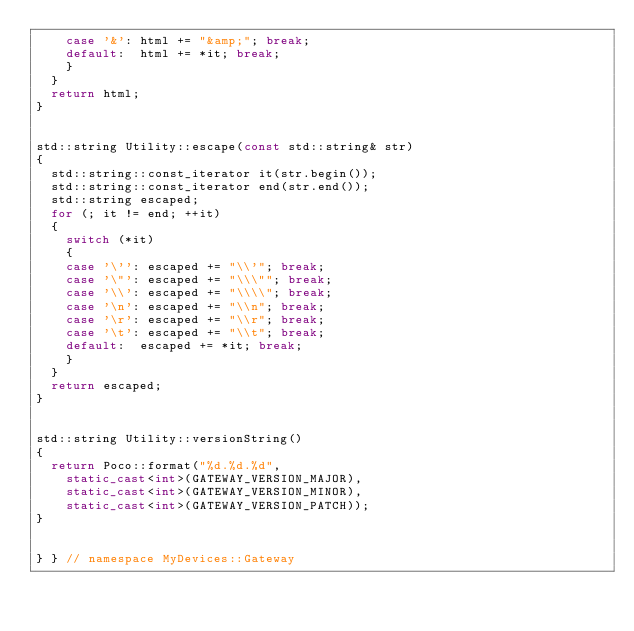Convert code to text. <code><loc_0><loc_0><loc_500><loc_500><_C++_>		case '&': html += "&amp;"; break;
		default:  html += *it; break;
		}
	}
	return html;
}


std::string Utility::escape(const std::string& str)
{
	std::string::const_iterator it(str.begin());
	std::string::const_iterator end(str.end());
	std::string escaped;
	for (; it != end; ++it)
	{
		switch (*it)
		{
		case '\'': escaped += "\\'"; break;
		case '\"': escaped += "\\\""; break;
		case '\\': escaped += "\\\\"; break;
		case '\n': escaped += "\\n"; break;
		case '\r': escaped += "\\r"; break;
		case '\t': escaped += "\\t"; break;
		default:  escaped += *it; break;
		}
	}
	return escaped;
}


std::string Utility::versionString()
{
	return Poco::format("%d.%d.%d",
		static_cast<int>(GATEWAY_VERSION_MAJOR),
		static_cast<int>(GATEWAY_VERSION_MINOR),
		static_cast<int>(GATEWAY_VERSION_PATCH));
}


} } // namespace MyDevices::Gateway
</code> 